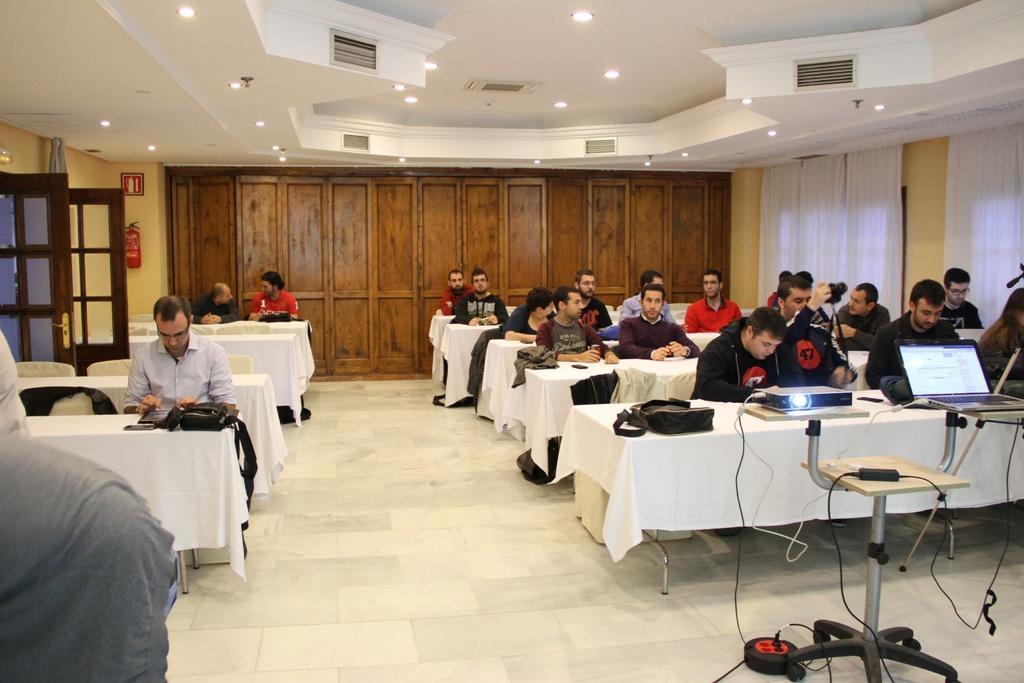Could you give a brief overview of what you see in this image? This picture shows a group of people seated on the chair and we see couple of bags on the tables and a projector and a laptop and a man holding a camera and we see few lights on the roof 